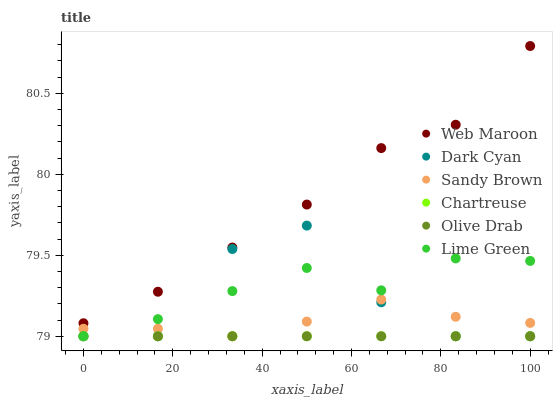Does Chartreuse have the minimum area under the curve?
Answer yes or no. Yes. Does Web Maroon have the maximum area under the curve?
Answer yes or no. Yes. Does Web Maroon have the minimum area under the curve?
Answer yes or no. No. Does Chartreuse have the maximum area under the curve?
Answer yes or no. No. Is Chartreuse the smoothest?
Answer yes or no. Yes. Is Dark Cyan the roughest?
Answer yes or no. Yes. Is Web Maroon the smoothest?
Answer yes or no. No. Is Web Maroon the roughest?
Answer yes or no. No. Does Lime Green have the lowest value?
Answer yes or no. Yes. Does Web Maroon have the lowest value?
Answer yes or no. No. Does Web Maroon have the highest value?
Answer yes or no. Yes. Does Chartreuse have the highest value?
Answer yes or no. No. Is Chartreuse less than Web Maroon?
Answer yes or no. Yes. Is Web Maroon greater than Sandy Brown?
Answer yes or no. Yes. Does Olive Drab intersect Lime Green?
Answer yes or no. Yes. Is Olive Drab less than Lime Green?
Answer yes or no. No. Is Olive Drab greater than Lime Green?
Answer yes or no. No. Does Chartreuse intersect Web Maroon?
Answer yes or no. No. 